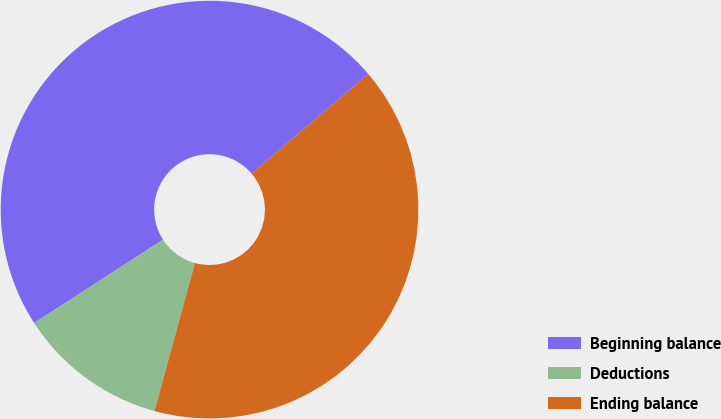Convert chart to OTSL. <chart><loc_0><loc_0><loc_500><loc_500><pie_chart><fcel>Beginning balance<fcel>Deductions<fcel>Ending balance<nl><fcel>47.88%<fcel>11.62%<fcel>40.5%<nl></chart> 